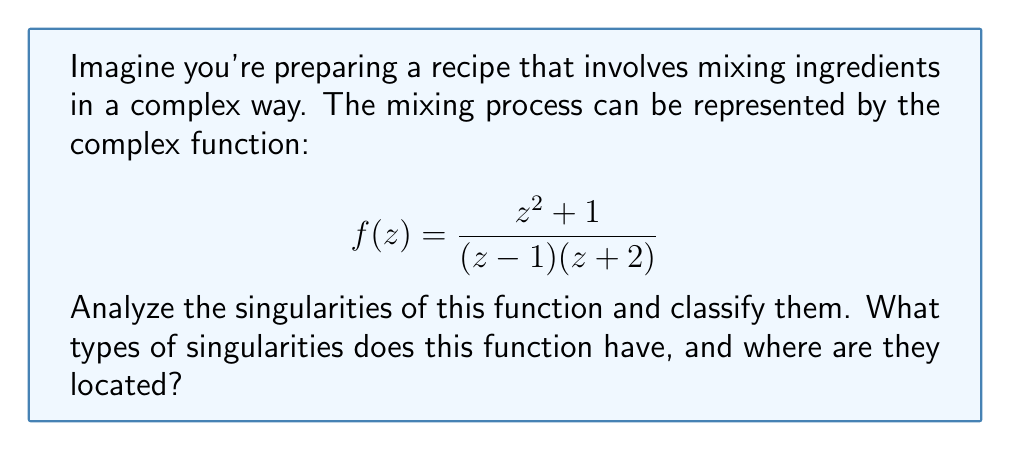Solve this math problem. Let's approach this step-by-step, like following a recipe:

1) First, we need to find the points where the function is not defined. These occur when the denominator equals zero:

   $$(z-1)(z+2) = 0$$

   This gives us two points: $z = 1$ and $z = -2$

2) Now, let's examine each point:

   For $z = 1$:
   $$\lim_{z \to 1} (z-1)f(z) = \lim_{z \to 1} \frac{z^2 + 1}{z+2} = \frac{1^2 + 1}{1+2} = \frac{2}{3}$$

   This limit exists and is finite, so $z = 1$ is a simple pole.

   For $z = -2$:
   $$\lim_{z \to -2} (z+2)f(z) = \lim_{z \to -2} \frac{z^2 + 1}{z-1} = \frac{(-2)^2 + 1}{-2-1} = \frac{5}{-3}$$

   This limit also exists and is finite, so $z = -2$ is also a simple pole.

3) To check for any other singularities, let's examine the behavior as $z \to \infty$:

   $$\lim_{z \to \infty} f(z) = \lim_{z \to \infty} \frac{z^2 + 1}{z^2 - z - 2} = 1$$

   This limit exists, so there's no singularity at infinity.

4) Finally, we should check if the numerator and denominator have any common factors that could cancel out. In this case, they don't.

Therefore, the function has two singularities, both of which are simple poles.
Answer: Two simple poles at $z = 1$ and $z = -2$ 